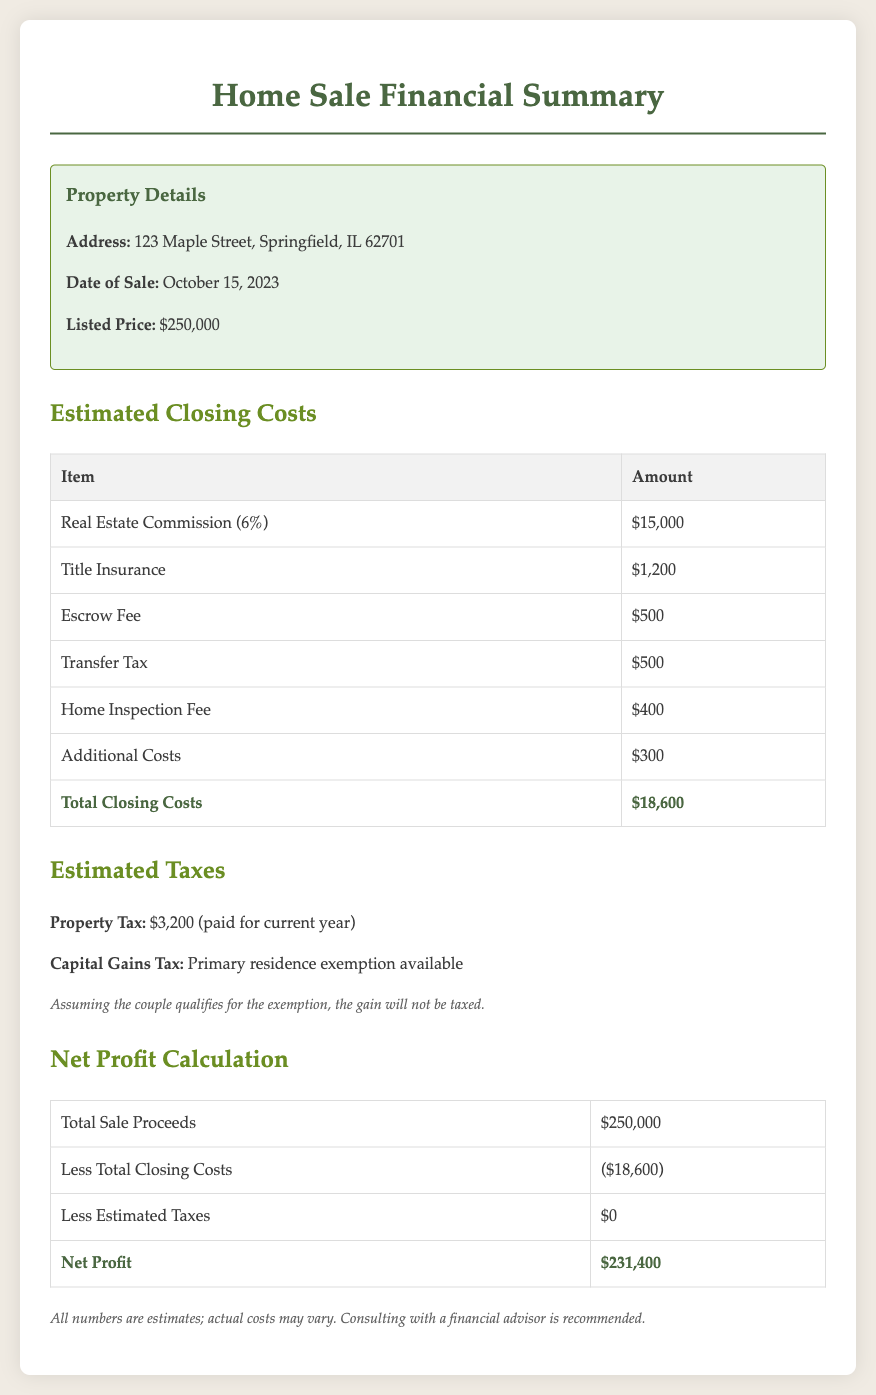What is the property address? The property address is specified in the document under Property Details.
Answer: 123 Maple Street, Springfield, IL 62701 What is the listed price of the home? The listed price is stated in the Property Details section of the document.
Answer: $250,000 What are the total closing costs? Total closing costs are summarized in the Estimated Closing Costs section of the document.
Answer: $18,600 What is the amount of property tax? The property tax amount is listed in the Estimated Taxes section.
Answer: $3,200 What is the net profit from the sale? The net profit is calculated in the Net Profit Calculation section, showing proceeds minus costs.
Answer: $231,400 Was the capital gains tax applicable? The document indicates whether a capital gains tax applies in the context of exemptions.
Answer: No How much was paid for the home inspection fee? The fee for the home inspection is detailed in the Estimated Closing Costs table.
Answer: $400 What date was the home sold? The date of sale is provided in the Property Details section of the document.
Answer: October 15, 2023 